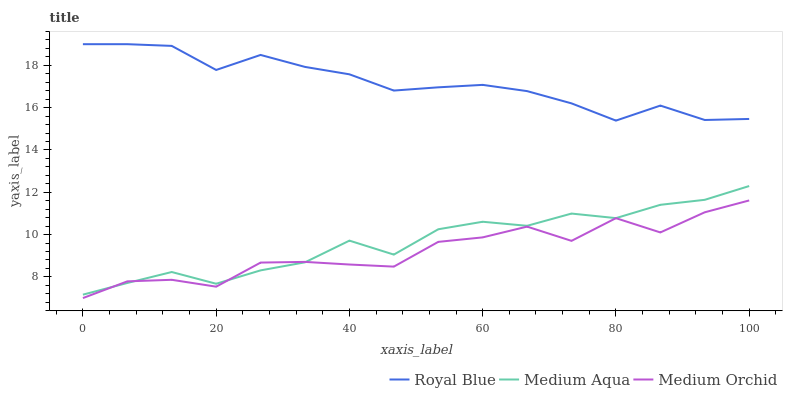Does Medium Orchid have the minimum area under the curve?
Answer yes or no. Yes. Does Royal Blue have the maximum area under the curve?
Answer yes or no. Yes. Does Medium Aqua have the minimum area under the curve?
Answer yes or no. No. Does Medium Aqua have the maximum area under the curve?
Answer yes or no. No. Is Royal Blue the smoothest?
Answer yes or no. Yes. Is Medium Orchid the roughest?
Answer yes or no. Yes. Is Medium Aqua the smoothest?
Answer yes or no. No. Is Medium Aqua the roughest?
Answer yes or no. No. Does Medium Orchid have the lowest value?
Answer yes or no. Yes. Does Medium Aqua have the lowest value?
Answer yes or no. No. Does Royal Blue have the highest value?
Answer yes or no. Yes. Does Medium Aqua have the highest value?
Answer yes or no. No. Is Medium Aqua less than Royal Blue?
Answer yes or no. Yes. Is Royal Blue greater than Medium Aqua?
Answer yes or no. Yes. Does Medium Aqua intersect Medium Orchid?
Answer yes or no. Yes. Is Medium Aqua less than Medium Orchid?
Answer yes or no. No. Is Medium Aqua greater than Medium Orchid?
Answer yes or no. No. Does Medium Aqua intersect Royal Blue?
Answer yes or no. No. 